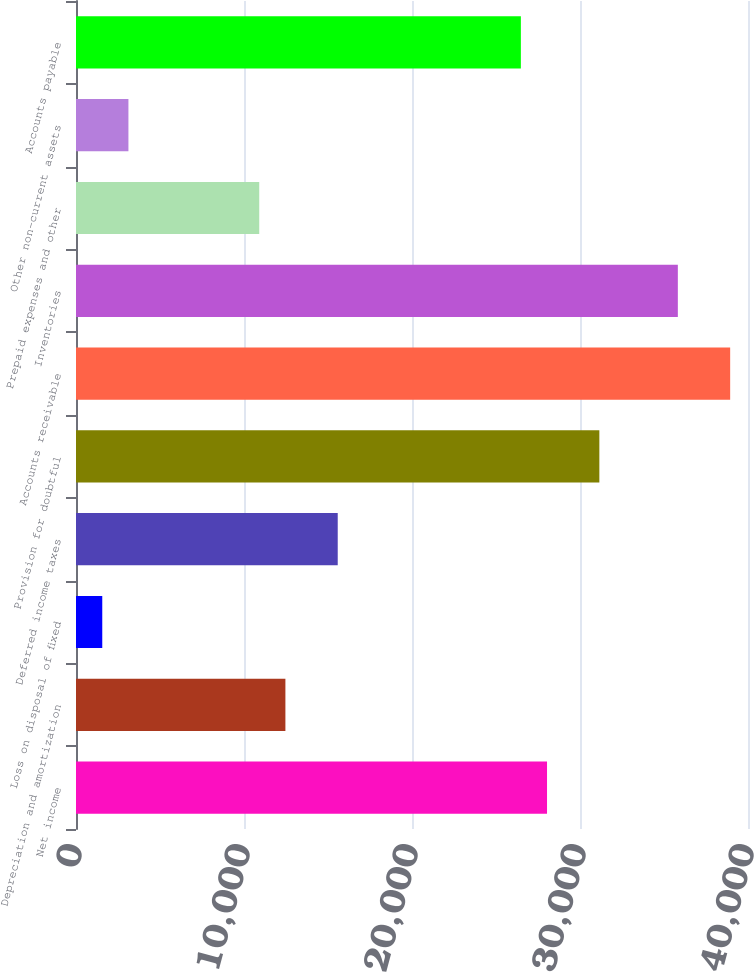<chart> <loc_0><loc_0><loc_500><loc_500><bar_chart><fcel>Net income<fcel>Depreciation and amortization<fcel>Loss on disposal of fixed<fcel>Deferred income taxes<fcel>Provision for doubtful<fcel>Accounts receivable<fcel>Inventories<fcel>Prepaid expenses and other<fcel>Other non-current assets<fcel>Accounts payable<nl><fcel>28037.4<fcel>12464.4<fcel>1563.3<fcel>15579<fcel>31152<fcel>38938.5<fcel>35823.9<fcel>10907.1<fcel>3120.6<fcel>26480.1<nl></chart> 